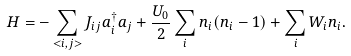<formula> <loc_0><loc_0><loc_500><loc_500>H = - \sum _ { < i , j > } J _ { i j } a ^ { \dagger } _ { i } a _ { j } + \frac { U _ { 0 } } { 2 } \sum _ { i } n _ { i } ( n _ { i } - 1 ) + \sum _ { i } W _ { i } n _ { i } .</formula> 